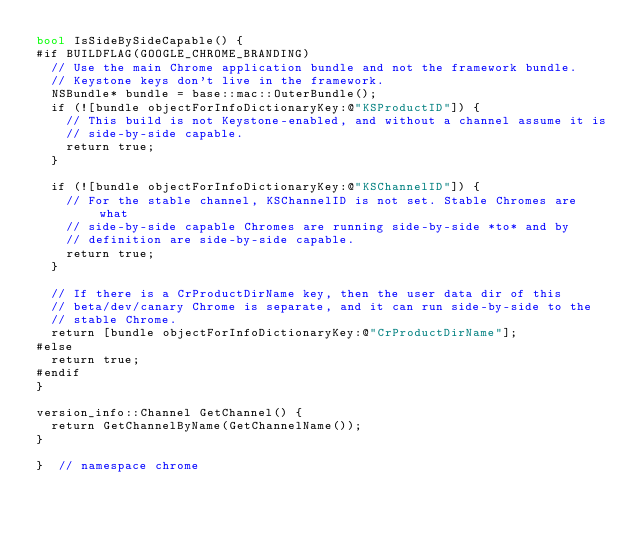Convert code to text. <code><loc_0><loc_0><loc_500><loc_500><_ObjectiveC_>bool IsSideBySideCapable() {
#if BUILDFLAG(GOOGLE_CHROME_BRANDING)
  // Use the main Chrome application bundle and not the framework bundle.
  // Keystone keys don't live in the framework.
  NSBundle* bundle = base::mac::OuterBundle();
  if (![bundle objectForInfoDictionaryKey:@"KSProductID"]) {
    // This build is not Keystone-enabled, and without a channel assume it is
    // side-by-side capable.
    return true;
  }

  if (![bundle objectForInfoDictionaryKey:@"KSChannelID"]) {
    // For the stable channel, KSChannelID is not set. Stable Chromes are what
    // side-by-side capable Chromes are running side-by-side *to* and by
    // definition are side-by-side capable.
    return true;
  }

  // If there is a CrProductDirName key, then the user data dir of this
  // beta/dev/canary Chrome is separate, and it can run side-by-side to the
  // stable Chrome.
  return [bundle objectForInfoDictionaryKey:@"CrProductDirName"];
#else
  return true;
#endif
}

version_info::Channel GetChannel() {
  return GetChannelByName(GetChannelName());
}

}  // namespace chrome
</code> 